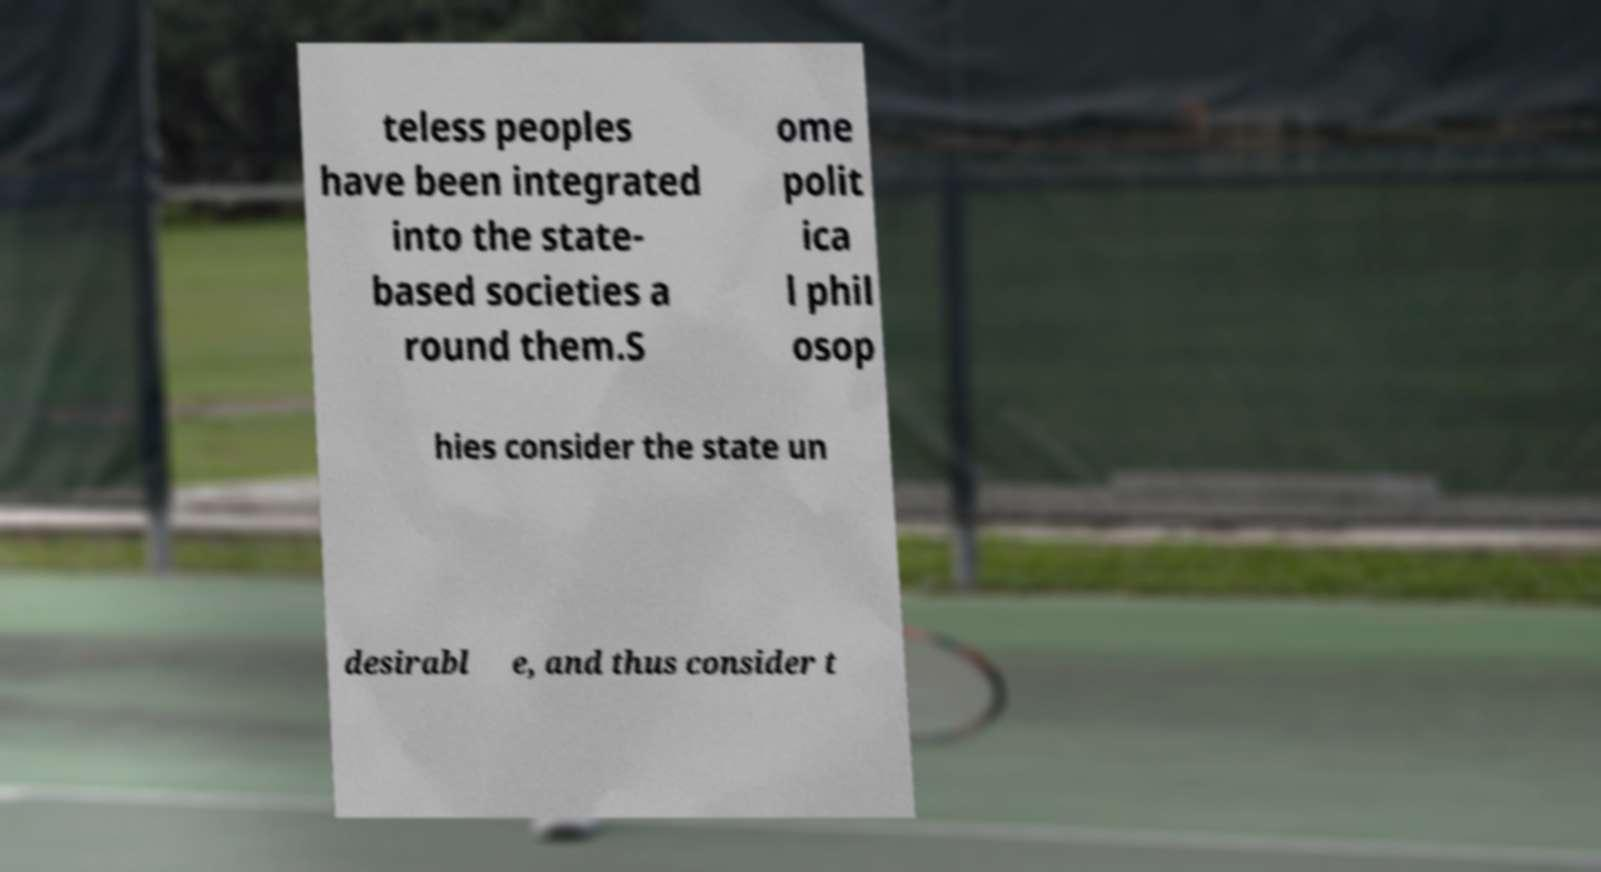There's text embedded in this image that I need extracted. Can you transcribe it verbatim? teless peoples have been integrated into the state- based societies a round them.S ome polit ica l phil osop hies consider the state un desirabl e, and thus consider t 